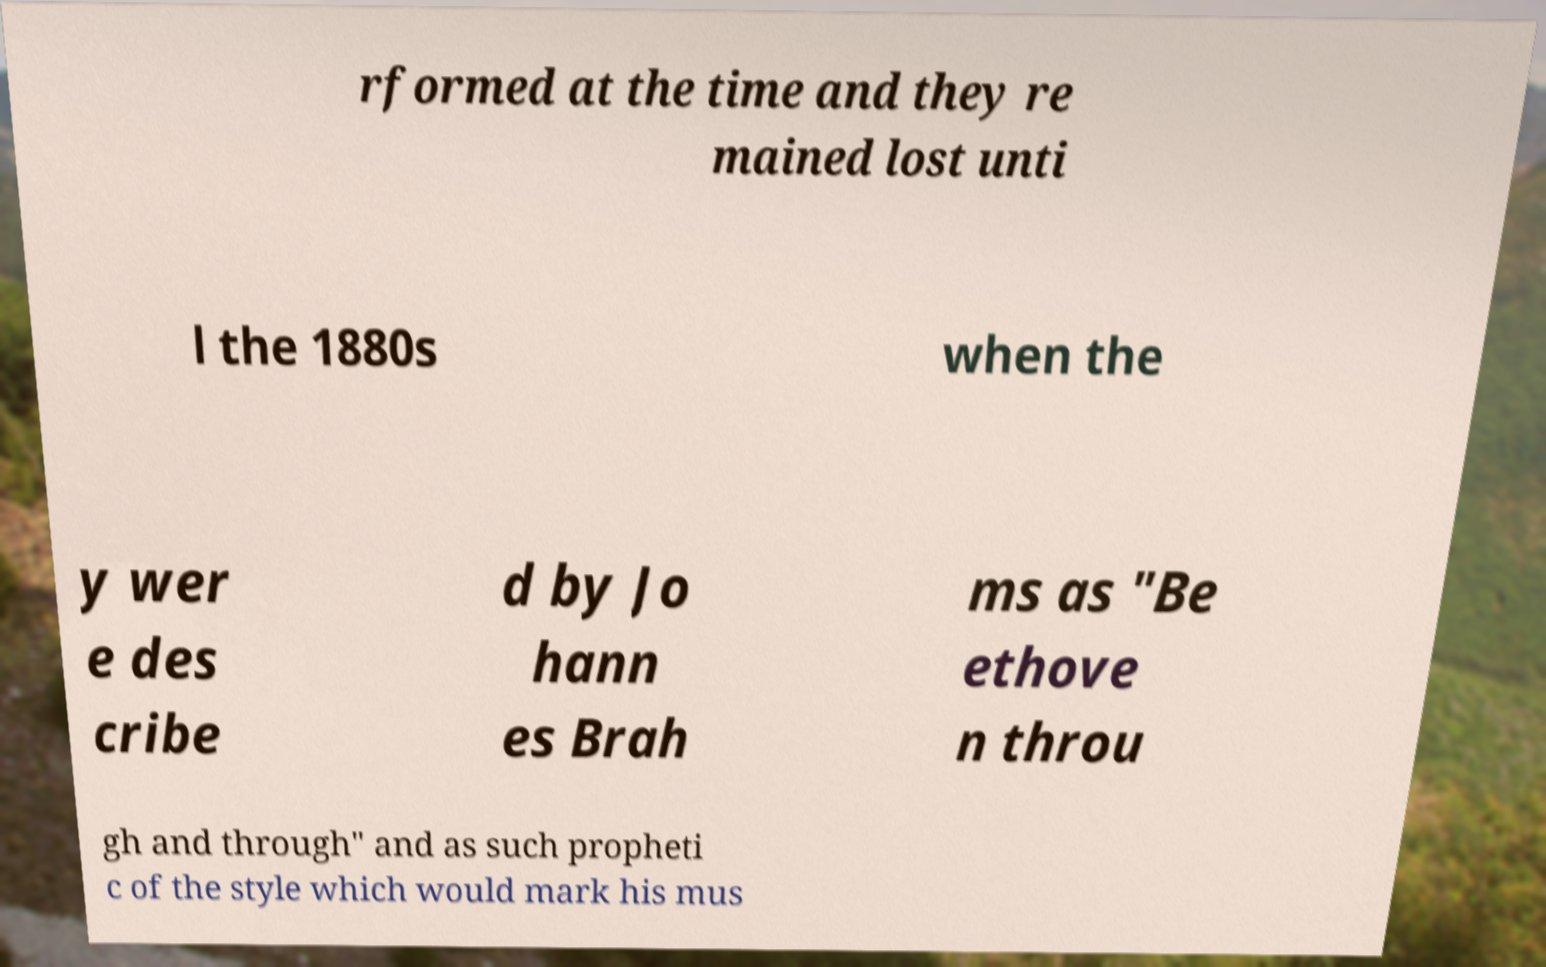Please identify and transcribe the text found in this image. rformed at the time and they re mained lost unti l the 1880s when the y wer e des cribe d by Jo hann es Brah ms as "Be ethove n throu gh and through" and as such propheti c of the style which would mark his mus 